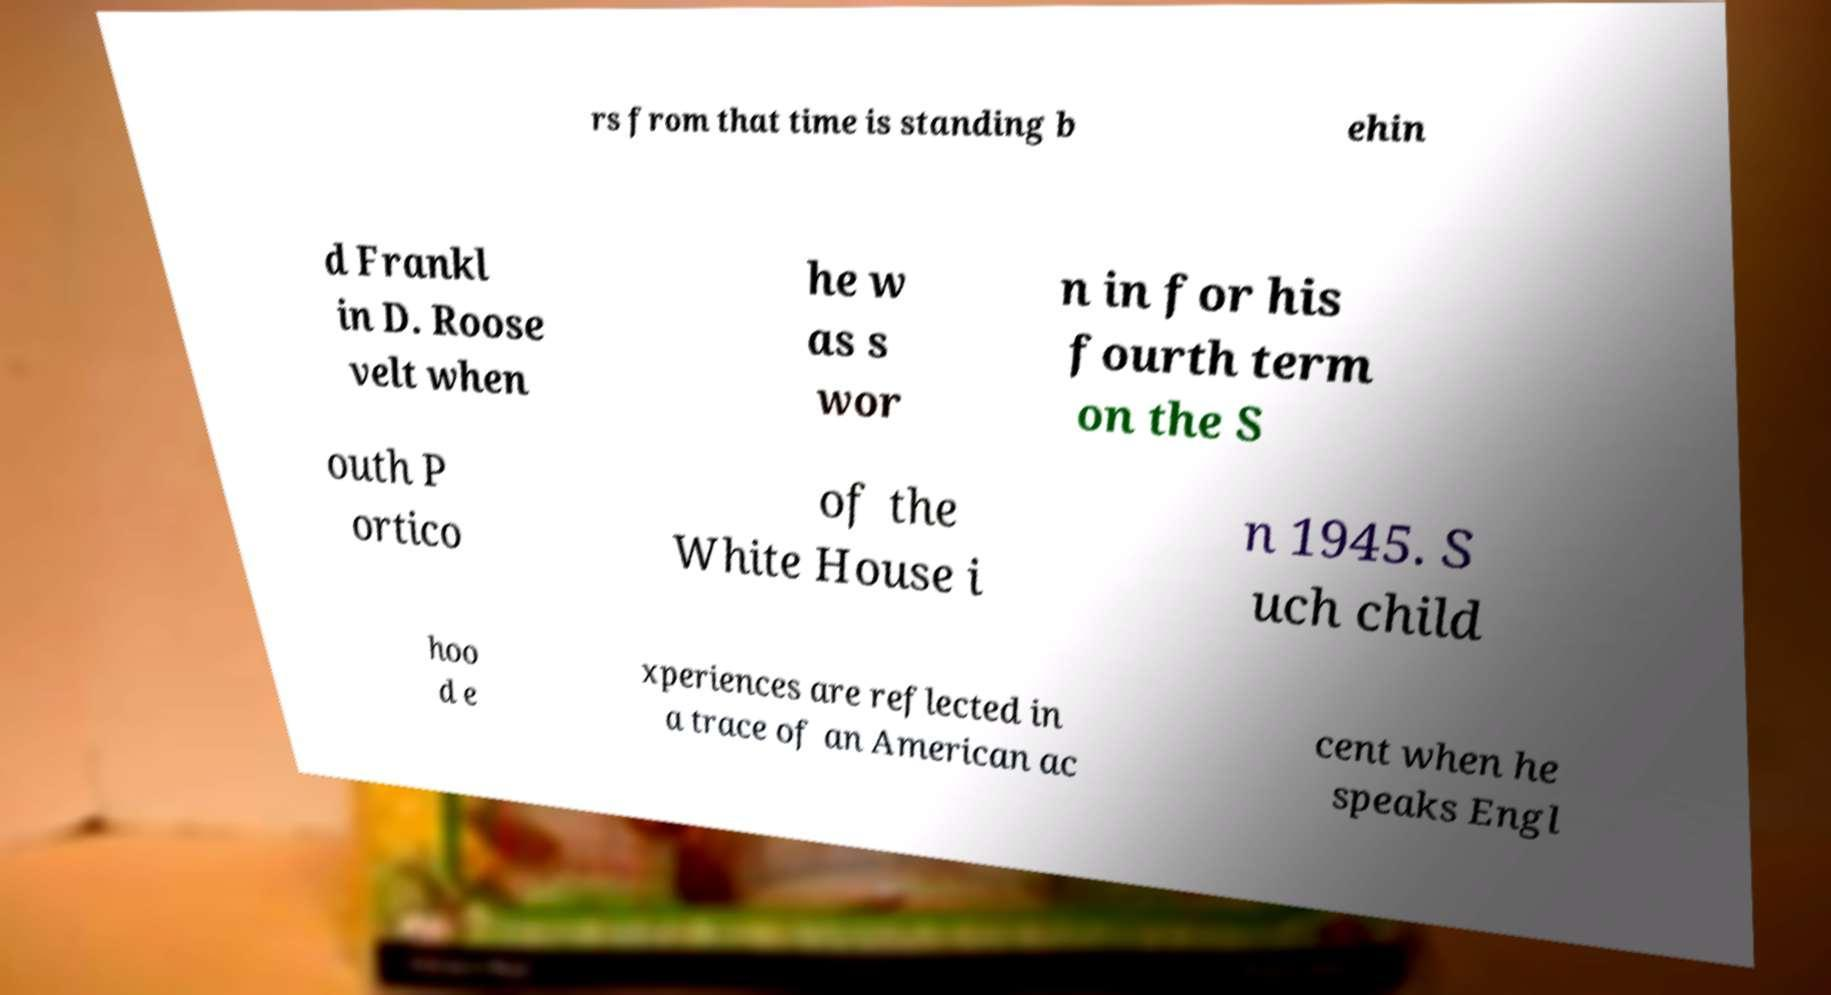Could you extract and type out the text from this image? rs from that time is standing b ehin d Frankl in D. Roose velt when he w as s wor n in for his fourth term on the S outh P ortico of the White House i n 1945. S uch child hoo d e xperiences are reflected in a trace of an American ac cent when he speaks Engl 